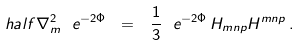Convert formula to latex. <formula><loc_0><loc_0><loc_500><loc_500>\ h a l f \nabla _ { m } ^ { 2 } \ e ^ { - 2 \Phi } \ = \ \frac { 1 } { 3 } \ e ^ { - 2 \Phi } \, H _ { m n p } H ^ { m n p } \, .</formula> 